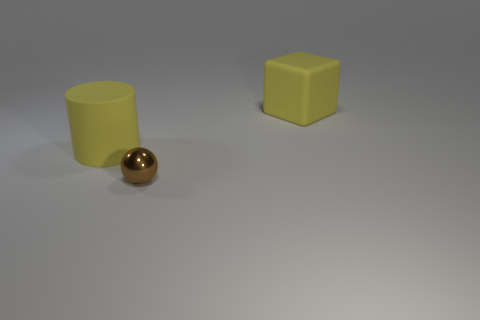Add 3 rubber spheres. How many objects exist? 6 Subtract all cylinders. How many objects are left? 2 Add 3 large objects. How many large objects are left? 5 Add 2 cyan things. How many cyan things exist? 2 Subtract 0 yellow balls. How many objects are left? 3 Subtract all large yellow rubber cylinders. Subtract all purple metal cylinders. How many objects are left? 2 